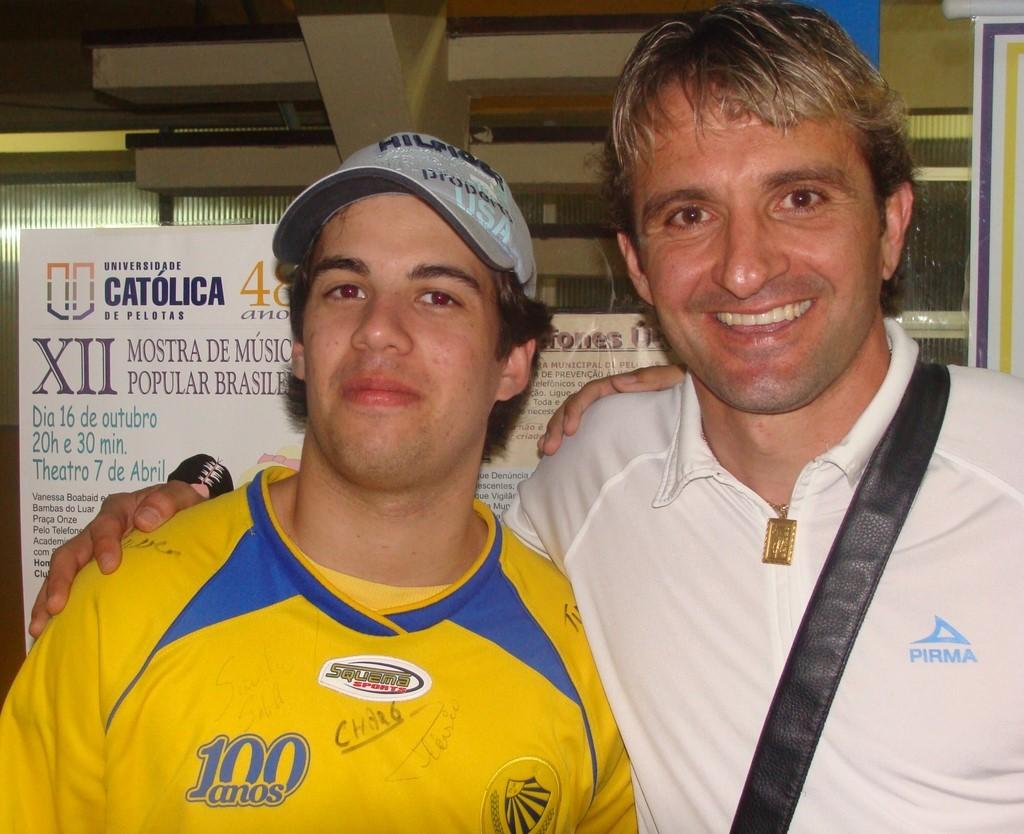<image>
Render a clear and concise summary of the photo. A guy has a yellow jersey on with 100 anos printed on the front. 